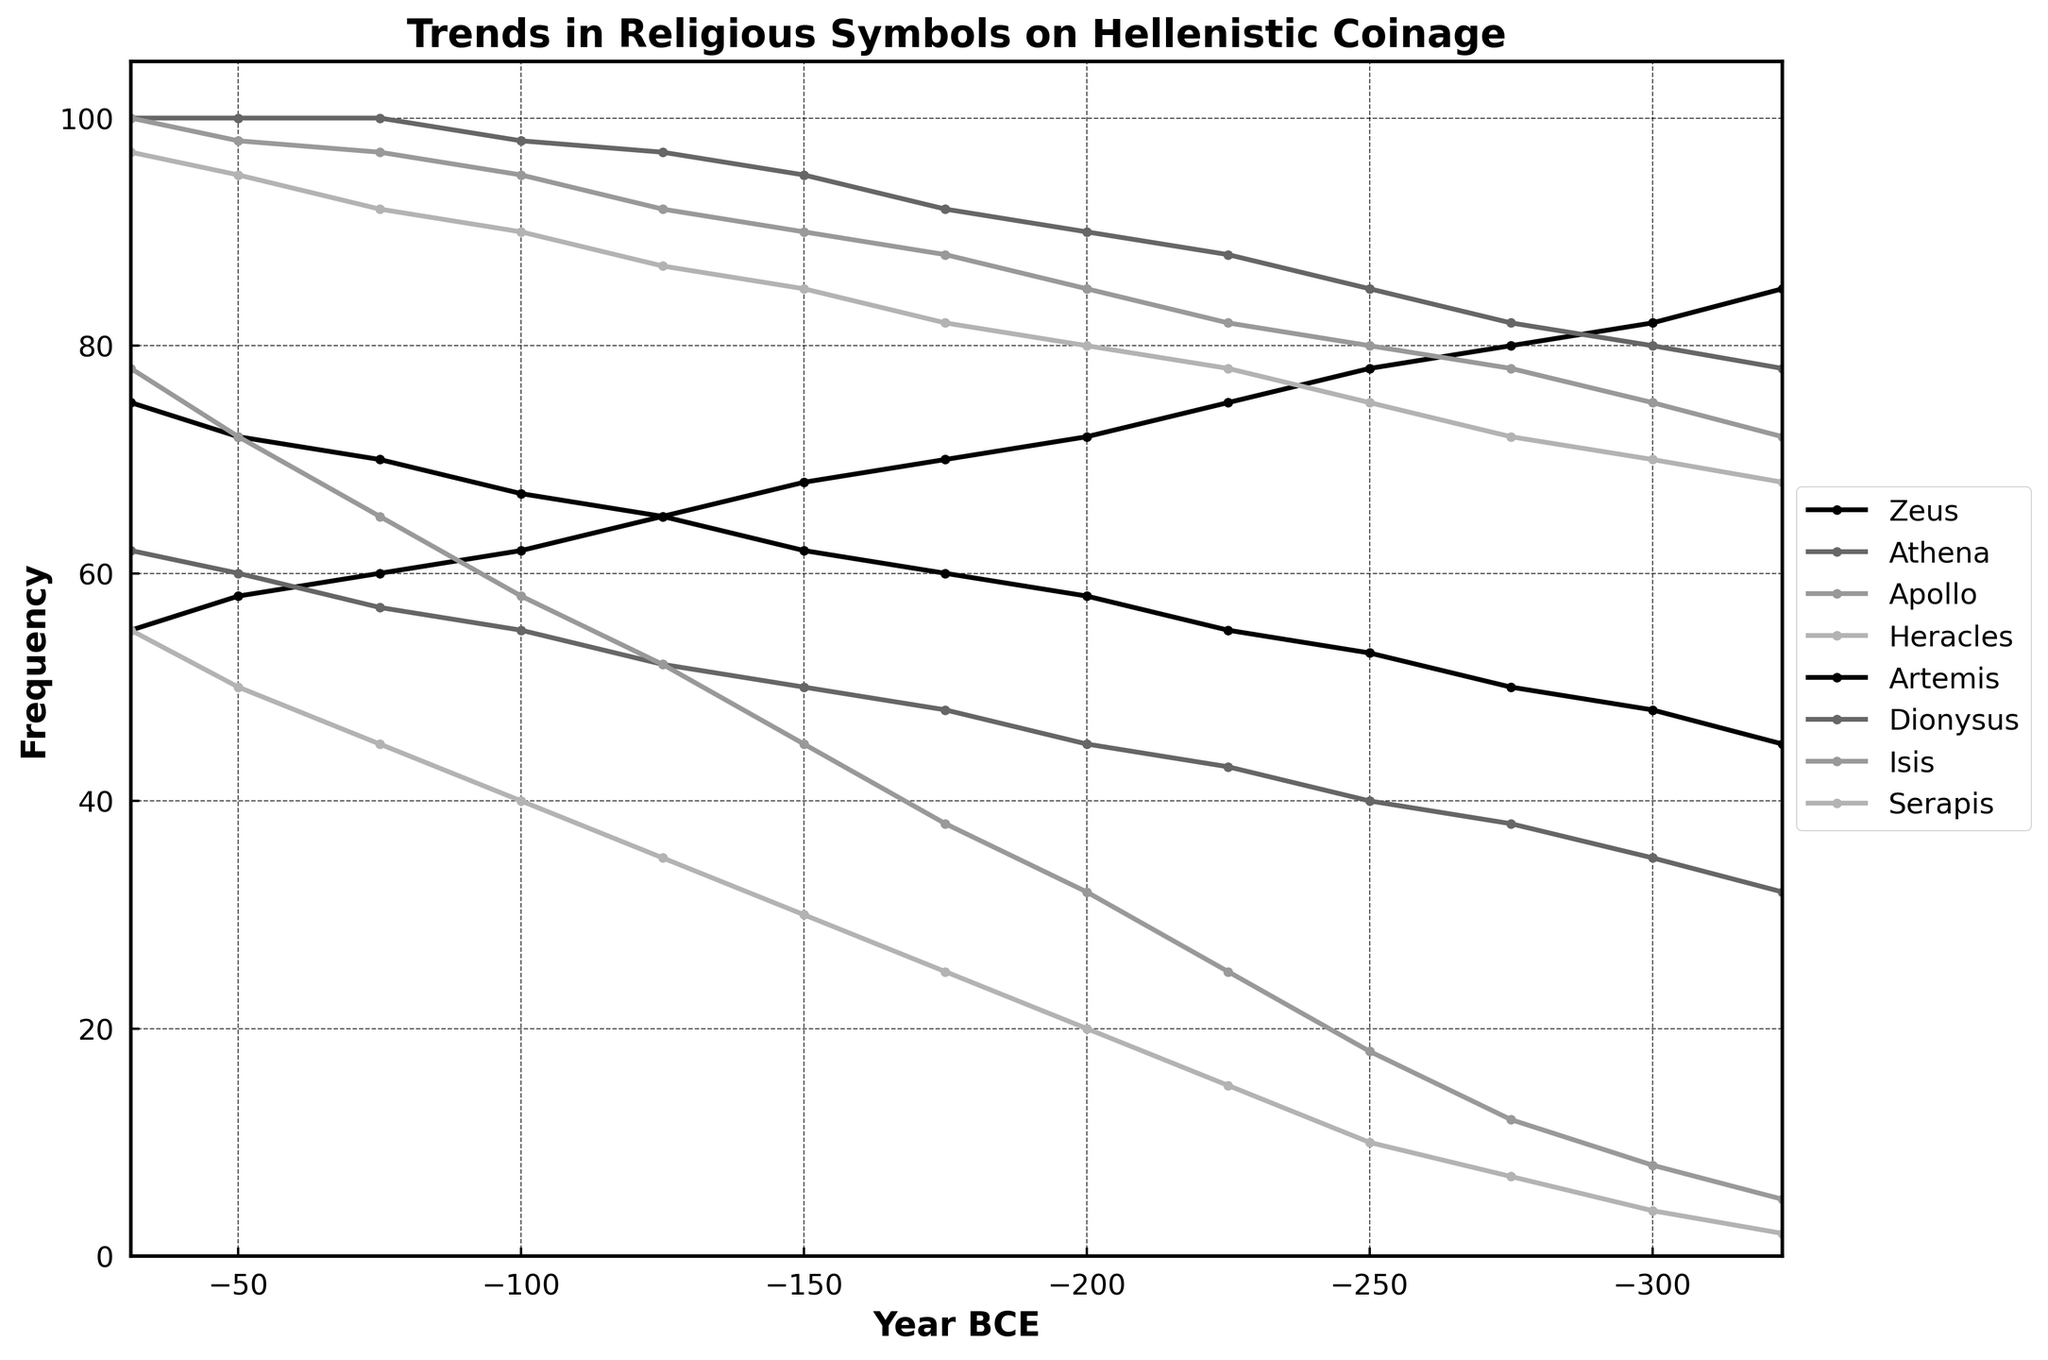What is the general trend of the use of Zeus' symbol on coinage throughout the Hellenistic period? The frequency of Zeus' symbol shows a declining trend from 85 in 323 BCE to 55 in 31 BCE. By observing the slope of the plot lines for Zeus over the years, the decreasing pattern is clear.
Answer: Declining Which deity’s symbol appears most frequently on coinage in 31 BCE? By inspecting the plots at 31 BCE, Athena's line is at 100, which is the highest point among all deities at this time.
Answer: Athena Between 275 BCE and 200 BCE, how did the use of Isis' symbol on coinage change, and by how much? To find the change, look at the values for Isis at 275 BCE and 200 BCE. The frequency increased from 12 to 32. The difference is calculated by subtracting the initial value from the final value: 32 - 12 = 20.
Answer: Increased by 20 Which deity shows a consistent increase in the frequency of their symbols throughout the entire period covered? By visually inspecting the plot lines from 323 BCE to 31 BCE, Athena shows a consistent upward trend without any decreases.
Answer: Athena In which period did Dionysus' symbol see the most significant increase, and how much did it increase by? Compare the changes between each pair of adjacent years. The most significant increase was between 125 BCE and 100 BCE, where the frequency increased from 52 to 55. The difference is calculated by subtracting 52 from 55: 55 - 52 = 33.
Answer: 125 BCE to 100 BCE, increased by 33 Compare the frequency of Artemis' symbol in 200 BCE and 50 BCE. Which is higher, and by how much? Look at the values for Artemis in 200 BCE and 50 BCE. The frequency in 200 BCE is 58 and in 50 BCE is 72. To find the difference, subtract the smaller value from the larger one: 72 - 58 = 14.
Answer: 50 BCE is higher by 14 Which two deities had the closest frequency of use in 323 BCE and what was the difference? Check the values for each deity in 323 BCE and find the closest pair. Athena (78) and Apollo (72) have the closest values. The difference is 78 - 72 = 6.
Answer: Athena and Apollo, difference of 6 What is the highest frequency observed for Serapis' symbol during the Hellenistic period, and in which year did this occur? By inspecting the plot, the highest value for Serapis is 55 in 31 BCE.
Answer: 55 in 31 BCE If we average the frequency of Apollo’s symbol over the years 300 BCE, 200 BCE, and 100 BCE, what is the result? Observe the values for Apollo in these years: 75 (300 BCE), 85 (200 BCE), and 95 (100 BCE). The average is calculated as (75 + 85 + 95) / 3 = 255 / 3 = 85.
Answer: 85 What is the difference in the frequency of Athena's symbol between the earliest and latest years in the dataset? In 323 BCE, Athena's frequency is 78, and in 31 BCE, it is 100. The difference is calculated by 100 - 78 = 22.
Answer: Difference of 22 